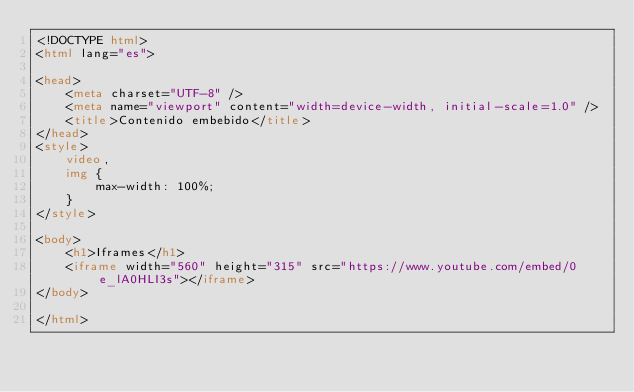Convert code to text. <code><loc_0><loc_0><loc_500><loc_500><_HTML_><!DOCTYPE html>
<html lang="es">

<head>
    <meta charset="UTF-8" />
    <meta name="viewport" content="width=device-width, initial-scale=1.0" />
    <title>Contenido embebido</title>
</head>
<style>
    video,
    img {
        max-width: 100%;
    }
</style>

<body>
    <h1>Iframes</h1>
    <iframe width="560" height="315" src="https://www.youtube.com/embed/0e_lA0HLI3s"></iframe>
</body>

</html></code> 